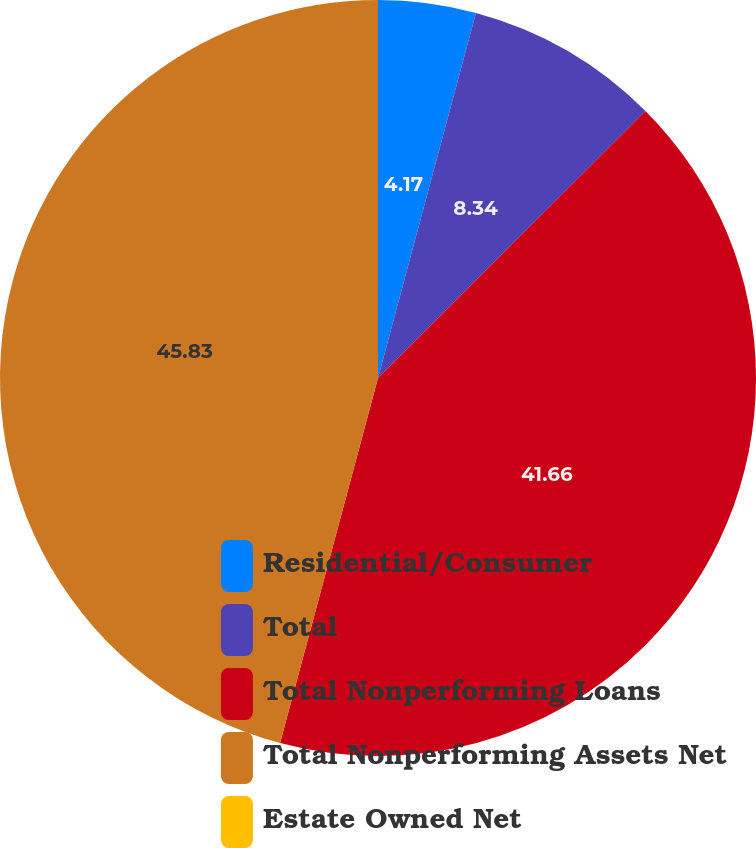Convert chart. <chart><loc_0><loc_0><loc_500><loc_500><pie_chart><fcel>Residential/Consumer<fcel>Total<fcel>Total Nonperforming Loans<fcel>Total Nonperforming Assets Net<fcel>Estate Owned Net<nl><fcel>4.17%<fcel>8.34%<fcel>41.66%<fcel>45.83%<fcel>0.0%<nl></chart> 